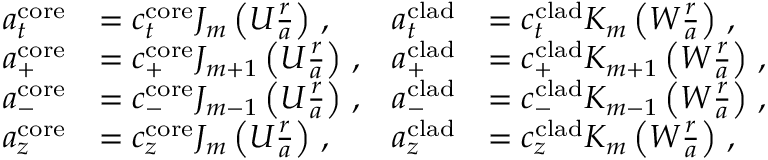<formula> <loc_0><loc_0><loc_500><loc_500>\begin{array} { r l r l } { a _ { t } ^ { c o r e } } & { = c _ { t } ^ { c o r e } J _ { m } \left ( U \frac { r } { a } \right ) \, , } & { a _ { t } ^ { c l a d } } & { = c _ { t } ^ { c l a d } K _ { m } \left ( W \frac { r } { a } \right ) \, , } \\ { a _ { + } ^ { c o r e } } & { = c _ { + } ^ { c o r e } J _ { m + 1 } \left ( U \frac { r } { a } \right ) \, , } & { a _ { + } ^ { c l a d } } & { = c _ { + } ^ { c l a d } K _ { m + 1 } \left ( W \frac { r } { a } \right ) \, , } \\ { a _ { - } ^ { c o r e } } & { = c _ { - } ^ { c o r e } J _ { m - 1 } \left ( U \frac { r } { a } \right ) \, , } & { a _ { - } ^ { c l a d } } & { = c _ { - } ^ { c l a d } K _ { m - 1 } \left ( W \frac { r } { a } \right ) \, , } \\ { a _ { z } ^ { c o r e } } & { = c _ { z } ^ { c o r e } J _ { m } \left ( U \frac { r } { a } \right ) \, , } & { a _ { z } ^ { c l a d } } & { = c _ { z } ^ { c l a d } K _ { m } \left ( W \frac { r } { a } \right ) \, , } \end{array}</formula> 